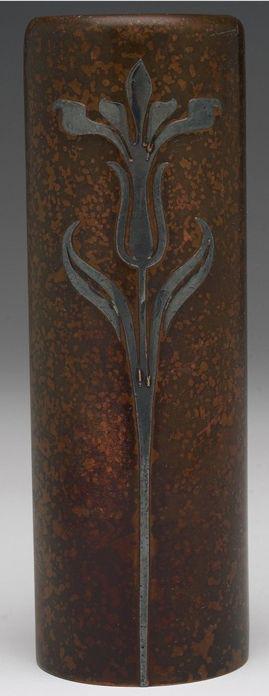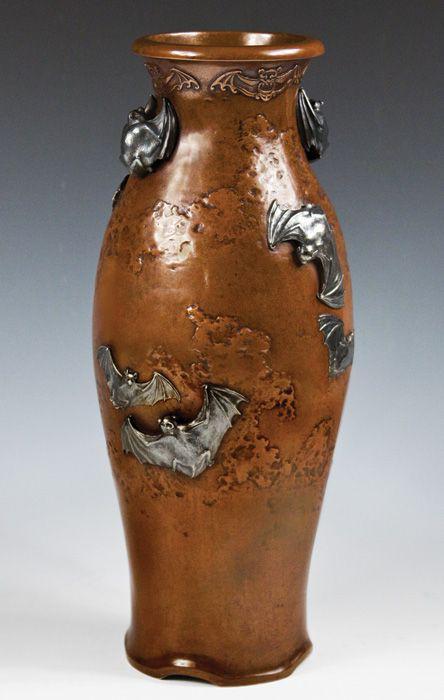The first image is the image on the left, the second image is the image on the right. Considering the images on both sides, is "An image includes a vase that tapers to a narrower base from a flat top and has a foliage-themed design on it." valid? Answer yes or no. No. The first image is the image on the left, the second image is the image on the right. Considering the images on both sides, is "One of the vases has a round opening, and at least one of the vases has a rectangular opening." valid? Answer yes or no. No. 